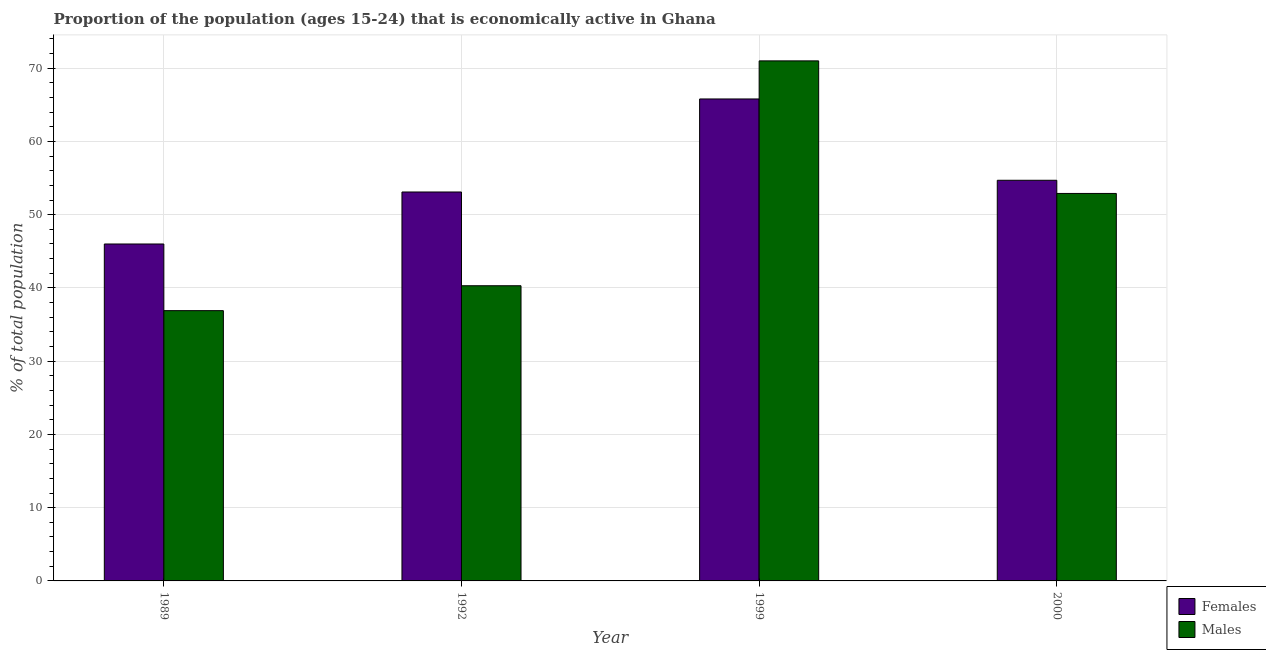How many different coloured bars are there?
Your answer should be compact. 2. How many groups of bars are there?
Your response must be concise. 4. Are the number of bars on each tick of the X-axis equal?
Your answer should be compact. Yes. How many bars are there on the 1st tick from the right?
Provide a succinct answer. 2. In how many cases, is the number of bars for a given year not equal to the number of legend labels?
Offer a very short reply. 0. What is the percentage of economically active female population in 1992?
Offer a terse response. 53.1. Across all years, what is the maximum percentage of economically active female population?
Ensure brevity in your answer.  65.8. Across all years, what is the minimum percentage of economically active male population?
Offer a very short reply. 36.9. In which year was the percentage of economically active female population minimum?
Offer a very short reply. 1989. What is the total percentage of economically active female population in the graph?
Your answer should be very brief. 219.6. What is the difference between the percentage of economically active female population in 1989 and that in 2000?
Keep it short and to the point. -8.7. What is the difference between the percentage of economically active female population in 1989 and the percentage of economically active male population in 1992?
Provide a succinct answer. -7.1. What is the average percentage of economically active male population per year?
Offer a very short reply. 50.28. What is the ratio of the percentage of economically active female population in 1992 to that in 2000?
Keep it short and to the point. 0.97. What is the difference between the highest and the second highest percentage of economically active male population?
Provide a short and direct response. 18.1. What is the difference between the highest and the lowest percentage of economically active female population?
Provide a short and direct response. 19.8. Is the sum of the percentage of economically active female population in 1989 and 2000 greater than the maximum percentage of economically active male population across all years?
Your answer should be compact. Yes. What does the 1st bar from the left in 1992 represents?
Give a very brief answer. Females. What does the 1st bar from the right in 2000 represents?
Offer a very short reply. Males. How many bars are there?
Provide a short and direct response. 8. Are all the bars in the graph horizontal?
Give a very brief answer. No. How many years are there in the graph?
Make the answer very short. 4. What is the difference between two consecutive major ticks on the Y-axis?
Keep it short and to the point. 10. Are the values on the major ticks of Y-axis written in scientific E-notation?
Ensure brevity in your answer.  No. Does the graph contain any zero values?
Keep it short and to the point. No. How many legend labels are there?
Your answer should be very brief. 2. How are the legend labels stacked?
Your answer should be compact. Vertical. What is the title of the graph?
Offer a very short reply. Proportion of the population (ages 15-24) that is economically active in Ghana. What is the label or title of the Y-axis?
Make the answer very short. % of total population. What is the % of total population of Males in 1989?
Your answer should be very brief. 36.9. What is the % of total population in Females in 1992?
Ensure brevity in your answer.  53.1. What is the % of total population of Males in 1992?
Offer a very short reply. 40.3. What is the % of total population in Females in 1999?
Provide a succinct answer. 65.8. What is the % of total population of Females in 2000?
Provide a short and direct response. 54.7. What is the % of total population in Males in 2000?
Keep it short and to the point. 52.9. Across all years, what is the maximum % of total population in Females?
Your answer should be very brief. 65.8. Across all years, what is the maximum % of total population in Males?
Keep it short and to the point. 71. Across all years, what is the minimum % of total population of Males?
Keep it short and to the point. 36.9. What is the total % of total population of Females in the graph?
Ensure brevity in your answer.  219.6. What is the total % of total population of Males in the graph?
Provide a succinct answer. 201.1. What is the difference between the % of total population of Females in 1989 and that in 1999?
Your response must be concise. -19.8. What is the difference between the % of total population of Males in 1989 and that in 1999?
Keep it short and to the point. -34.1. What is the difference between the % of total population in Males in 1989 and that in 2000?
Offer a very short reply. -16. What is the difference between the % of total population in Males in 1992 and that in 1999?
Make the answer very short. -30.7. What is the difference between the % of total population of Females in 1992 and that in 2000?
Your answer should be compact. -1.6. What is the difference between the % of total population in Males in 1999 and that in 2000?
Ensure brevity in your answer.  18.1. What is the difference between the % of total population of Females in 1989 and the % of total population of Males in 1992?
Make the answer very short. 5.7. What is the difference between the % of total population of Females in 1989 and the % of total population of Males in 1999?
Your answer should be very brief. -25. What is the difference between the % of total population in Females in 1992 and the % of total population in Males in 1999?
Make the answer very short. -17.9. What is the difference between the % of total population of Females in 1999 and the % of total population of Males in 2000?
Provide a succinct answer. 12.9. What is the average % of total population in Females per year?
Your answer should be very brief. 54.9. What is the average % of total population of Males per year?
Give a very brief answer. 50.27. In the year 1989, what is the difference between the % of total population of Females and % of total population of Males?
Ensure brevity in your answer.  9.1. In the year 1992, what is the difference between the % of total population of Females and % of total population of Males?
Keep it short and to the point. 12.8. In the year 1999, what is the difference between the % of total population of Females and % of total population of Males?
Make the answer very short. -5.2. In the year 2000, what is the difference between the % of total population in Females and % of total population in Males?
Make the answer very short. 1.8. What is the ratio of the % of total population of Females in 1989 to that in 1992?
Your answer should be compact. 0.87. What is the ratio of the % of total population of Males in 1989 to that in 1992?
Make the answer very short. 0.92. What is the ratio of the % of total population of Females in 1989 to that in 1999?
Your answer should be very brief. 0.7. What is the ratio of the % of total population in Males in 1989 to that in 1999?
Keep it short and to the point. 0.52. What is the ratio of the % of total population of Females in 1989 to that in 2000?
Offer a terse response. 0.84. What is the ratio of the % of total population in Males in 1989 to that in 2000?
Keep it short and to the point. 0.7. What is the ratio of the % of total population of Females in 1992 to that in 1999?
Give a very brief answer. 0.81. What is the ratio of the % of total population in Males in 1992 to that in 1999?
Keep it short and to the point. 0.57. What is the ratio of the % of total population in Females in 1992 to that in 2000?
Offer a very short reply. 0.97. What is the ratio of the % of total population of Males in 1992 to that in 2000?
Your answer should be very brief. 0.76. What is the ratio of the % of total population of Females in 1999 to that in 2000?
Offer a very short reply. 1.2. What is the ratio of the % of total population in Males in 1999 to that in 2000?
Keep it short and to the point. 1.34. What is the difference between the highest and the second highest % of total population in Females?
Provide a short and direct response. 11.1. What is the difference between the highest and the second highest % of total population in Males?
Provide a succinct answer. 18.1. What is the difference between the highest and the lowest % of total population of Females?
Your answer should be compact. 19.8. What is the difference between the highest and the lowest % of total population in Males?
Offer a terse response. 34.1. 